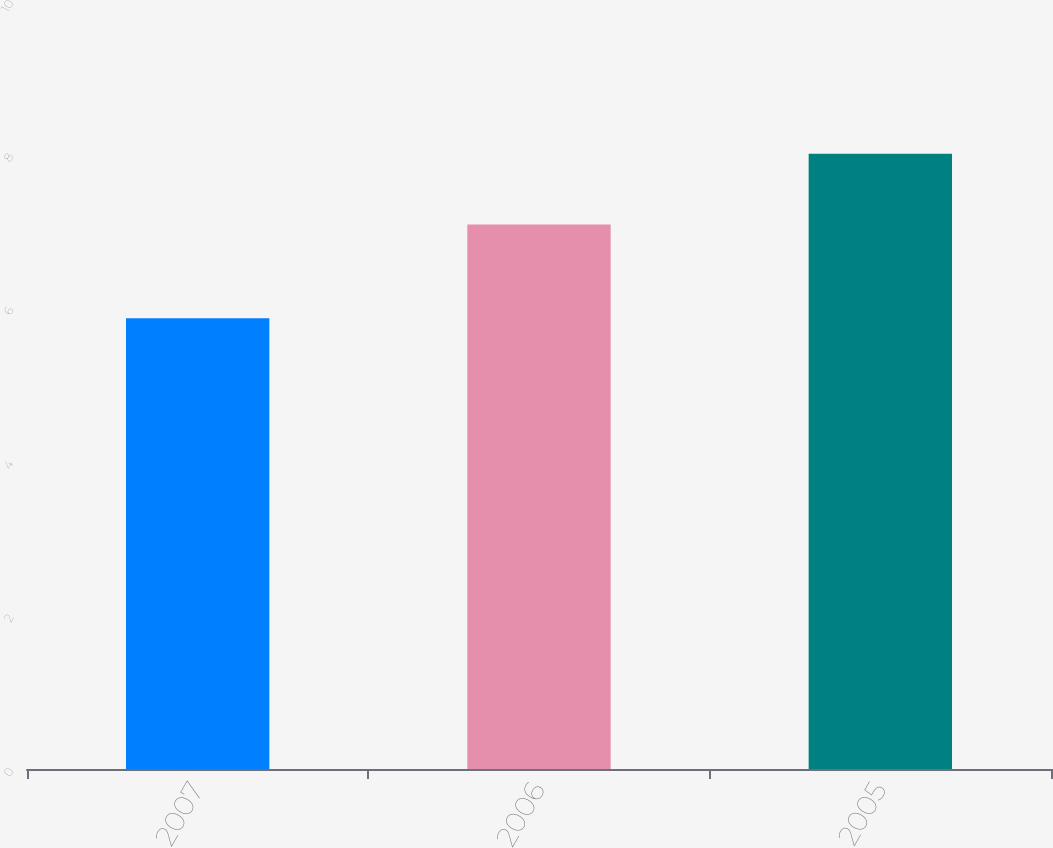Convert chart to OTSL. <chart><loc_0><loc_0><loc_500><loc_500><bar_chart><fcel>2007<fcel>2006<fcel>2005<nl><fcel>5.87<fcel>7.09<fcel>8.01<nl></chart> 